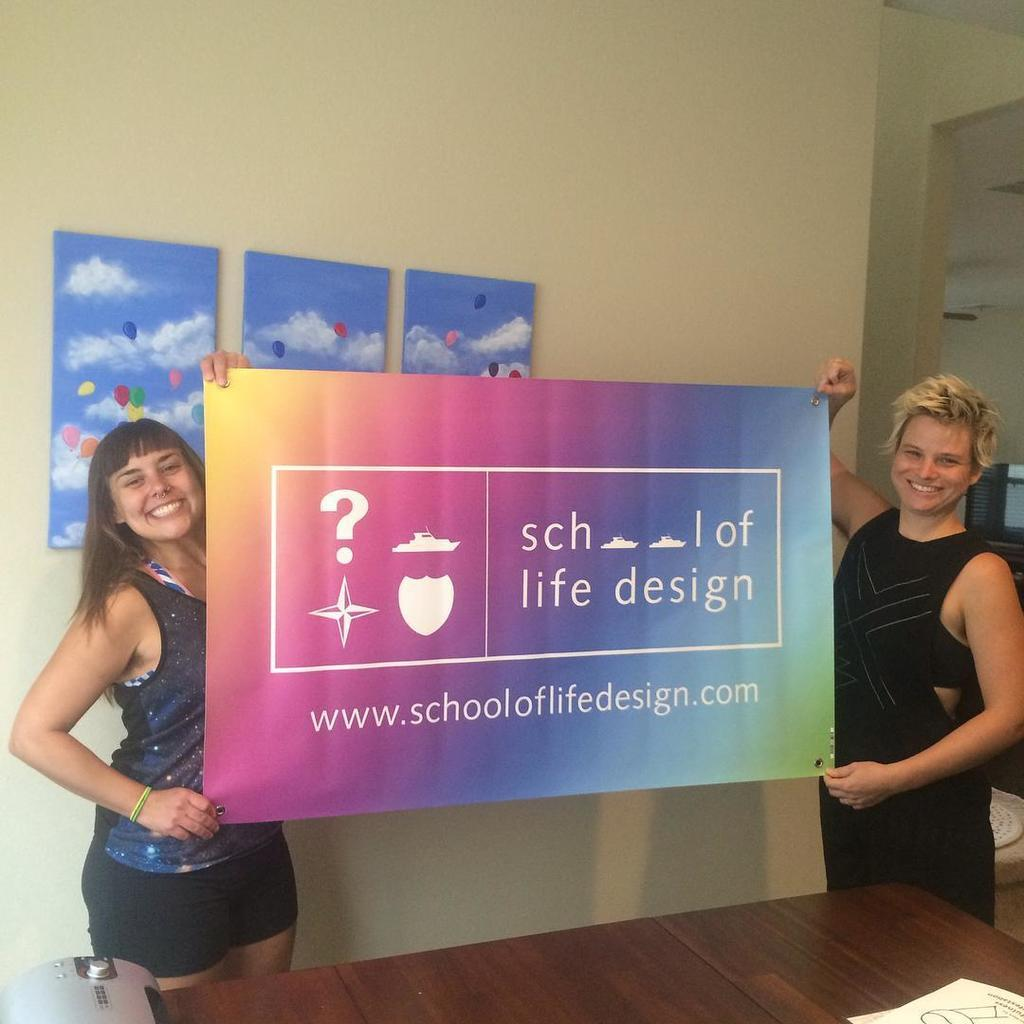How many people are in the image? There are two people in the image. What are the two people holding? The two people are holding colorful boards. What can be seen on the table in the image? There are objects on a table in the image. What is attached to the wall in the image? There are frames attached to the wall in the image. What type of debt is being discussed in the image? There is no mention of debt in the image; it features two people holding colorful boards and objects on a table. Can you see a boot on the desk in the image? There is no desk or boot present in the image. 